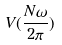<formula> <loc_0><loc_0><loc_500><loc_500>V ( \frac { N \omega } { 2 \pi } )</formula> 